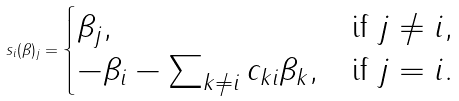Convert formula to latex. <formula><loc_0><loc_0><loc_500><loc_500>s _ { i } ( \beta ) _ { j } = \begin{cases} \beta _ { j } , & \text {if $j \neq i$} , \\ - \beta _ { i } - \sum _ { k \neq i } c _ { k i } \beta _ { k } , & \text {if $j = i$} . \end{cases}</formula> 